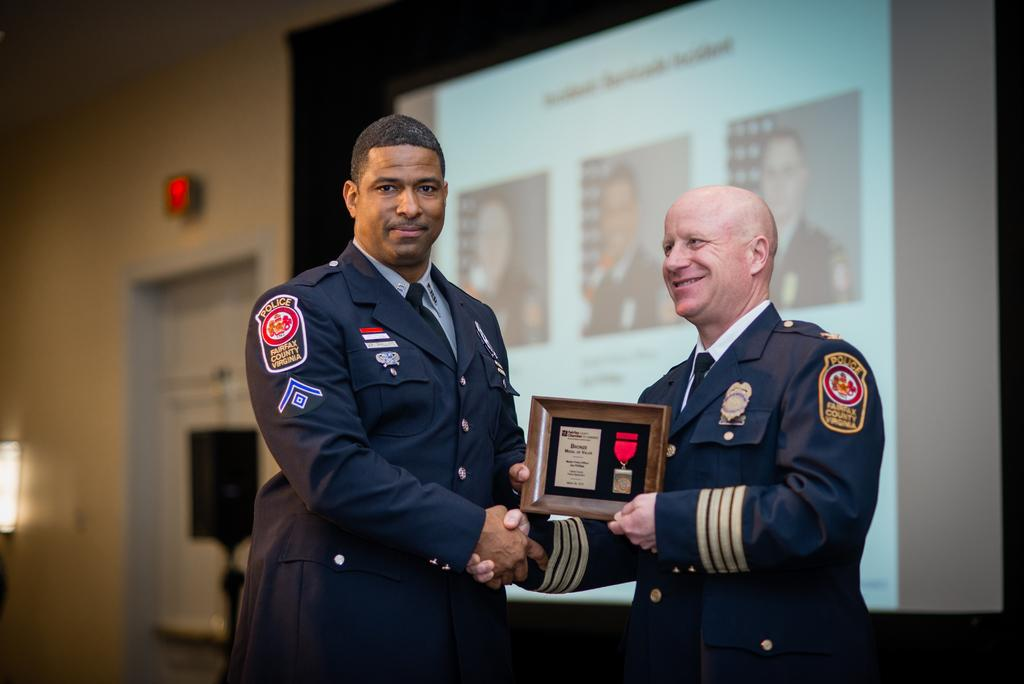What are the persons in the image doing? The persons in the image are standing in the center and holding a frame. What can be seen in the background of the image? There is a door and a wall in the background of the image. What type of club is the person working at in the image? There is no club or person working in the image; it only shows persons holding a frame. 